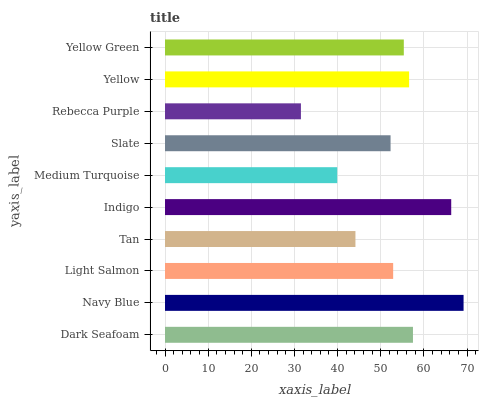Is Rebecca Purple the minimum?
Answer yes or no. Yes. Is Navy Blue the maximum?
Answer yes or no. Yes. Is Light Salmon the minimum?
Answer yes or no. No. Is Light Salmon the maximum?
Answer yes or no. No. Is Navy Blue greater than Light Salmon?
Answer yes or no. Yes. Is Light Salmon less than Navy Blue?
Answer yes or no. Yes. Is Light Salmon greater than Navy Blue?
Answer yes or no. No. Is Navy Blue less than Light Salmon?
Answer yes or no. No. Is Yellow Green the high median?
Answer yes or no. Yes. Is Light Salmon the low median?
Answer yes or no. Yes. Is Slate the high median?
Answer yes or no. No. Is Slate the low median?
Answer yes or no. No. 